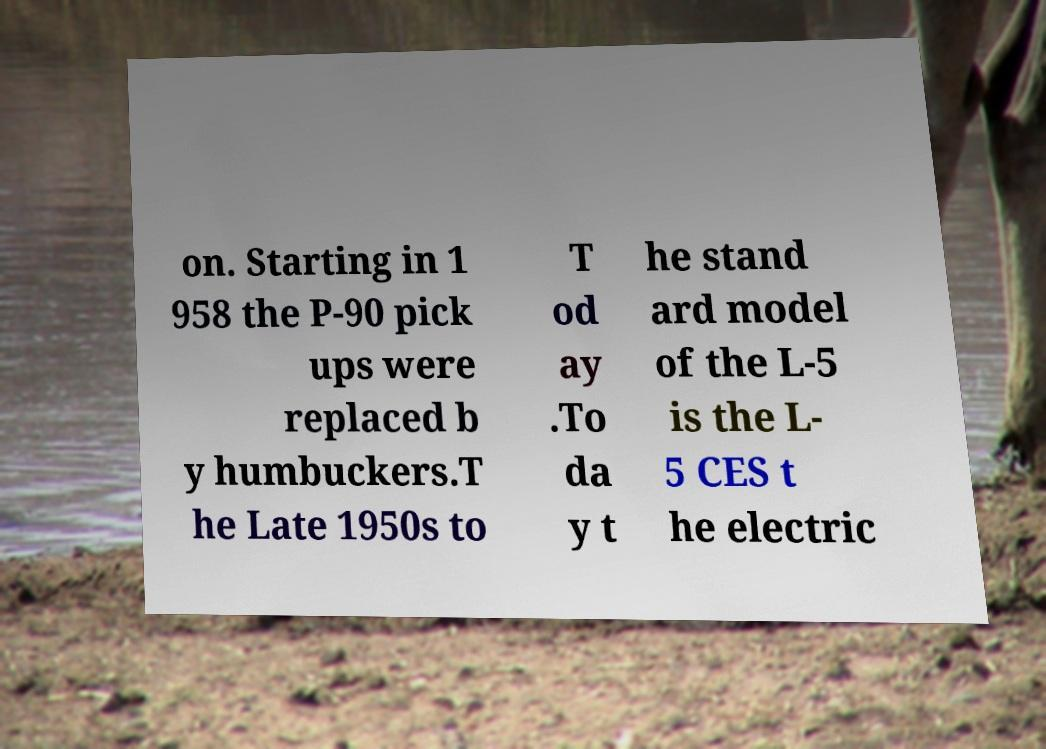I need the written content from this picture converted into text. Can you do that? on. Starting in 1 958 the P-90 pick ups were replaced b y humbuckers.T he Late 1950s to T od ay .To da y t he stand ard model of the L-5 is the L- 5 CES t he electric 